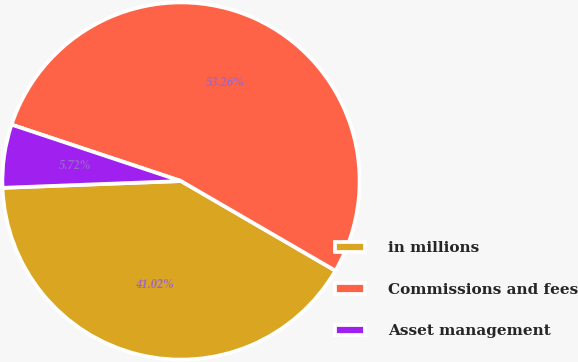Convert chart. <chart><loc_0><loc_0><loc_500><loc_500><pie_chart><fcel>in millions<fcel>Commissions and fees<fcel>Asset management<nl><fcel>41.02%<fcel>53.26%<fcel>5.72%<nl></chart> 